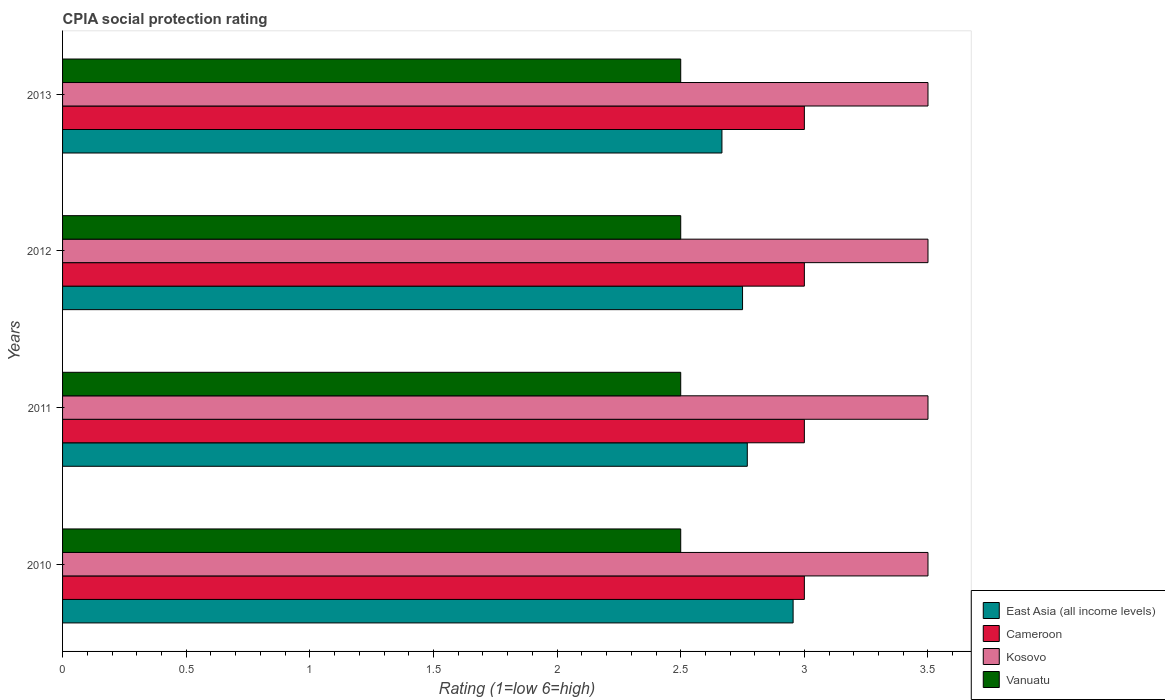How many different coloured bars are there?
Your response must be concise. 4. How many groups of bars are there?
Ensure brevity in your answer.  4. Are the number of bars per tick equal to the number of legend labels?
Your answer should be compact. Yes. Are the number of bars on each tick of the Y-axis equal?
Provide a short and direct response. Yes. How many bars are there on the 3rd tick from the top?
Your answer should be compact. 4. How many bars are there on the 1st tick from the bottom?
Your answer should be compact. 4. What is the label of the 2nd group of bars from the top?
Give a very brief answer. 2012. In how many cases, is the number of bars for a given year not equal to the number of legend labels?
Your answer should be very brief. 0. Across all years, what is the maximum CPIA rating in Cameroon?
Offer a terse response. 3. In which year was the CPIA rating in Vanuatu minimum?
Offer a very short reply. 2010. What is the difference between the CPIA rating in Cameroon in 2010 and that in 2013?
Give a very brief answer. 0. What is the ratio of the CPIA rating in East Asia (all income levels) in 2012 to that in 2013?
Your response must be concise. 1.03. Is the difference between the CPIA rating in East Asia (all income levels) in 2010 and 2012 greater than the difference between the CPIA rating in Cameroon in 2010 and 2012?
Give a very brief answer. Yes. What is the difference between the highest and the lowest CPIA rating in Cameroon?
Your response must be concise. 0. In how many years, is the CPIA rating in Kosovo greater than the average CPIA rating in Kosovo taken over all years?
Provide a succinct answer. 0. Is it the case that in every year, the sum of the CPIA rating in Cameroon and CPIA rating in East Asia (all income levels) is greater than the sum of CPIA rating in Kosovo and CPIA rating in Vanuatu?
Your answer should be compact. No. What does the 1st bar from the top in 2010 represents?
Your response must be concise. Vanuatu. What does the 4th bar from the bottom in 2011 represents?
Provide a short and direct response. Vanuatu. Is it the case that in every year, the sum of the CPIA rating in Vanuatu and CPIA rating in East Asia (all income levels) is greater than the CPIA rating in Cameroon?
Ensure brevity in your answer.  Yes. How many bars are there?
Give a very brief answer. 16. Are all the bars in the graph horizontal?
Your response must be concise. Yes. How many years are there in the graph?
Your answer should be compact. 4. What is the difference between two consecutive major ticks on the X-axis?
Provide a succinct answer. 0.5. Are the values on the major ticks of X-axis written in scientific E-notation?
Offer a terse response. No. Where does the legend appear in the graph?
Give a very brief answer. Bottom right. How are the legend labels stacked?
Keep it short and to the point. Vertical. What is the title of the graph?
Give a very brief answer. CPIA social protection rating. Does "Iceland" appear as one of the legend labels in the graph?
Your answer should be compact. No. What is the label or title of the Y-axis?
Your answer should be very brief. Years. What is the Rating (1=low 6=high) in East Asia (all income levels) in 2010?
Offer a very short reply. 2.95. What is the Rating (1=low 6=high) of Cameroon in 2010?
Provide a short and direct response. 3. What is the Rating (1=low 6=high) of Kosovo in 2010?
Give a very brief answer. 3.5. What is the Rating (1=low 6=high) in East Asia (all income levels) in 2011?
Provide a short and direct response. 2.77. What is the Rating (1=low 6=high) in Cameroon in 2011?
Offer a terse response. 3. What is the Rating (1=low 6=high) of Vanuatu in 2011?
Your answer should be very brief. 2.5. What is the Rating (1=low 6=high) in East Asia (all income levels) in 2012?
Make the answer very short. 2.75. What is the Rating (1=low 6=high) in Kosovo in 2012?
Give a very brief answer. 3.5. What is the Rating (1=low 6=high) of Vanuatu in 2012?
Provide a short and direct response. 2.5. What is the Rating (1=low 6=high) of East Asia (all income levels) in 2013?
Give a very brief answer. 2.67. What is the Rating (1=low 6=high) of Cameroon in 2013?
Your answer should be very brief. 3. Across all years, what is the maximum Rating (1=low 6=high) in East Asia (all income levels)?
Provide a short and direct response. 2.95. Across all years, what is the maximum Rating (1=low 6=high) in Cameroon?
Offer a terse response. 3. Across all years, what is the maximum Rating (1=low 6=high) of Vanuatu?
Offer a very short reply. 2.5. Across all years, what is the minimum Rating (1=low 6=high) in East Asia (all income levels)?
Your answer should be very brief. 2.67. Across all years, what is the minimum Rating (1=low 6=high) of Vanuatu?
Your response must be concise. 2.5. What is the total Rating (1=low 6=high) in East Asia (all income levels) in the graph?
Offer a very short reply. 11.14. What is the total Rating (1=low 6=high) in Cameroon in the graph?
Provide a short and direct response. 12. What is the total Rating (1=low 6=high) of Kosovo in the graph?
Your answer should be very brief. 14. What is the total Rating (1=low 6=high) of Vanuatu in the graph?
Keep it short and to the point. 10. What is the difference between the Rating (1=low 6=high) in East Asia (all income levels) in 2010 and that in 2011?
Provide a short and direct response. 0.19. What is the difference between the Rating (1=low 6=high) of Vanuatu in 2010 and that in 2011?
Make the answer very short. 0. What is the difference between the Rating (1=low 6=high) of East Asia (all income levels) in 2010 and that in 2012?
Keep it short and to the point. 0.2. What is the difference between the Rating (1=low 6=high) in Cameroon in 2010 and that in 2012?
Keep it short and to the point. 0. What is the difference between the Rating (1=low 6=high) of East Asia (all income levels) in 2010 and that in 2013?
Your answer should be compact. 0.29. What is the difference between the Rating (1=low 6=high) of Vanuatu in 2010 and that in 2013?
Provide a short and direct response. 0. What is the difference between the Rating (1=low 6=high) of East Asia (all income levels) in 2011 and that in 2012?
Provide a succinct answer. 0.02. What is the difference between the Rating (1=low 6=high) in East Asia (all income levels) in 2011 and that in 2013?
Make the answer very short. 0.1. What is the difference between the Rating (1=low 6=high) of Kosovo in 2011 and that in 2013?
Your response must be concise. 0. What is the difference between the Rating (1=low 6=high) of Vanuatu in 2011 and that in 2013?
Keep it short and to the point. 0. What is the difference between the Rating (1=low 6=high) in East Asia (all income levels) in 2012 and that in 2013?
Provide a succinct answer. 0.08. What is the difference between the Rating (1=low 6=high) in Cameroon in 2012 and that in 2013?
Offer a very short reply. 0. What is the difference between the Rating (1=low 6=high) in Kosovo in 2012 and that in 2013?
Your response must be concise. 0. What is the difference between the Rating (1=low 6=high) of Vanuatu in 2012 and that in 2013?
Your answer should be compact. 0. What is the difference between the Rating (1=low 6=high) of East Asia (all income levels) in 2010 and the Rating (1=low 6=high) of Cameroon in 2011?
Offer a terse response. -0.05. What is the difference between the Rating (1=low 6=high) of East Asia (all income levels) in 2010 and the Rating (1=low 6=high) of Kosovo in 2011?
Ensure brevity in your answer.  -0.55. What is the difference between the Rating (1=low 6=high) in East Asia (all income levels) in 2010 and the Rating (1=low 6=high) in Vanuatu in 2011?
Provide a short and direct response. 0.45. What is the difference between the Rating (1=low 6=high) of Cameroon in 2010 and the Rating (1=low 6=high) of Vanuatu in 2011?
Make the answer very short. 0.5. What is the difference between the Rating (1=low 6=high) in East Asia (all income levels) in 2010 and the Rating (1=low 6=high) in Cameroon in 2012?
Ensure brevity in your answer.  -0.05. What is the difference between the Rating (1=low 6=high) in East Asia (all income levels) in 2010 and the Rating (1=low 6=high) in Kosovo in 2012?
Keep it short and to the point. -0.55. What is the difference between the Rating (1=low 6=high) of East Asia (all income levels) in 2010 and the Rating (1=low 6=high) of Vanuatu in 2012?
Keep it short and to the point. 0.45. What is the difference between the Rating (1=low 6=high) of Cameroon in 2010 and the Rating (1=low 6=high) of Kosovo in 2012?
Your response must be concise. -0.5. What is the difference between the Rating (1=low 6=high) of Cameroon in 2010 and the Rating (1=low 6=high) of Vanuatu in 2012?
Keep it short and to the point. 0.5. What is the difference between the Rating (1=low 6=high) of East Asia (all income levels) in 2010 and the Rating (1=low 6=high) of Cameroon in 2013?
Your answer should be very brief. -0.05. What is the difference between the Rating (1=low 6=high) in East Asia (all income levels) in 2010 and the Rating (1=low 6=high) in Kosovo in 2013?
Offer a terse response. -0.55. What is the difference between the Rating (1=low 6=high) in East Asia (all income levels) in 2010 and the Rating (1=low 6=high) in Vanuatu in 2013?
Make the answer very short. 0.45. What is the difference between the Rating (1=low 6=high) in Cameroon in 2010 and the Rating (1=low 6=high) in Vanuatu in 2013?
Provide a succinct answer. 0.5. What is the difference between the Rating (1=low 6=high) in Kosovo in 2010 and the Rating (1=low 6=high) in Vanuatu in 2013?
Offer a terse response. 1. What is the difference between the Rating (1=low 6=high) in East Asia (all income levels) in 2011 and the Rating (1=low 6=high) in Cameroon in 2012?
Make the answer very short. -0.23. What is the difference between the Rating (1=low 6=high) of East Asia (all income levels) in 2011 and the Rating (1=low 6=high) of Kosovo in 2012?
Your response must be concise. -0.73. What is the difference between the Rating (1=low 6=high) of East Asia (all income levels) in 2011 and the Rating (1=low 6=high) of Vanuatu in 2012?
Give a very brief answer. 0.27. What is the difference between the Rating (1=low 6=high) of Cameroon in 2011 and the Rating (1=low 6=high) of Vanuatu in 2012?
Your answer should be very brief. 0.5. What is the difference between the Rating (1=low 6=high) in East Asia (all income levels) in 2011 and the Rating (1=low 6=high) in Cameroon in 2013?
Make the answer very short. -0.23. What is the difference between the Rating (1=low 6=high) of East Asia (all income levels) in 2011 and the Rating (1=low 6=high) of Kosovo in 2013?
Give a very brief answer. -0.73. What is the difference between the Rating (1=low 6=high) of East Asia (all income levels) in 2011 and the Rating (1=low 6=high) of Vanuatu in 2013?
Your response must be concise. 0.27. What is the difference between the Rating (1=low 6=high) of Cameroon in 2011 and the Rating (1=low 6=high) of Kosovo in 2013?
Your answer should be very brief. -0.5. What is the difference between the Rating (1=low 6=high) of Cameroon in 2011 and the Rating (1=low 6=high) of Vanuatu in 2013?
Make the answer very short. 0.5. What is the difference between the Rating (1=low 6=high) of East Asia (all income levels) in 2012 and the Rating (1=low 6=high) of Kosovo in 2013?
Your answer should be compact. -0.75. What is the difference between the Rating (1=low 6=high) of Cameroon in 2012 and the Rating (1=low 6=high) of Kosovo in 2013?
Provide a succinct answer. -0.5. What is the difference between the Rating (1=low 6=high) in Kosovo in 2012 and the Rating (1=low 6=high) in Vanuatu in 2013?
Give a very brief answer. 1. What is the average Rating (1=low 6=high) in East Asia (all income levels) per year?
Keep it short and to the point. 2.79. What is the average Rating (1=low 6=high) of Cameroon per year?
Make the answer very short. 3. What is the average Rating (1=low 6=high) in Kosovo per year?
Offer a very short reply. 3.5. What is the average Rating (1=low 6=high) of Vanuatu per year?
Your answer should be compact. 2.5. In the year 2010, what is the difference between the Rating (1=low 6=high) of East Asia (all income levels) and Rating (1=low 6=high) of Cameroon?
Provide a short and direct response. -0.05. In the year 2010, what is the difference between the Rating (1=low 6=high) of East Asia (all income levels) and Rating (1=low 6=high) of Kosovo?
Keep it short and to the point. -0.55. In the year 2010, what is the difference between the Rating (1=low 6=high) of East Asia (all income levels) and Rating (1=low 6=high) of Vanuatu?
Offer a terse response. 0.45. In the year 2010, what is the difference between the Rating (1=low 6=high) in Cameroon and Rating (1=low 6=high) in Vanuatu?
Make the answer very short. 0.5. In the year 2011, what is the difference between the Rating (1=low 6=high) of East Asia (all income levels) and Rating (1=low 6=high) of Cameroon?
Provide a short and direct response. -0.23. In the year 2011, what is the difference between the Rating (1=low 6=high) of East Asia (all income levels) and Rating (1=low 6=high) of Kosovo?
Keep it short and to the point. -0.73. In the year 2011, what is the difference between the Rating (1=low 6=high) of East Asia (all income levels) and Rating (1=low 6=high) of Vanuatu?
Your response must be concise. 0.27. In the year 2011, what is the difference between the Rating (1=low 6=high) in Cameroon and Rating (1=low 6=high) in Kosovo?
Your answer should be compact. -0.5. In the year 2011, what is the difference between the Rating (1=low 6=high) of Kosovo and Rating (1=low 6=high) of Vanuatu?
Provide a succinct answer. 1. In the year 2012, what is the difference between the Rating (1=low 6=high) in East Asia (all income levels) and Rating (1=low 6=high) in Kosovo?
Provide a succinct answer. -0.75. In the year 2012, what is the difference between the Rating (1=low 6=high) in East Asia (all income levels) and Rating (1=low 6=high) in Vanuatu?
Your answer should be very brief. 0.25. In the year 2012, what is the difference between the Rating (1=low 6=high) in Cameroon and Rating (1=low 6=high) in Vanuatu?
Ensure brevity in your answer.  0.5. In the year 2013, what is the difference between the Rating (1=low 6=high) of East Asia (all income levels) and Rating (1=low 6=high) of Kosovo?
Provide a succinct answer. -0.83. In the year 2013, what is the difference between the Rating (1=low 6=high) of East Asia (all income levels) and Rating (1=low 6=high) of Vanuatu?
Offer a terse response. 0.17. In the year 2013, what is the difference between the Rating (1=low 6=high) of Cameroon and Rating (1=low 6=high) of Kosovo?
Give a very brief answer. -0.5. What is the ratio of the Rating (1=low 6=high) in East Asia (all income levels) in 2010 to that in 2011?
Your answer should be very brief. 1.07. What is the ratio of the Rating (1=low 6=high) in East Asia (all income levels) in 2010 to that in 2012?
Provide a succinct answer. 1.07. What is the ratio of the Rating (1=low 6=high) of Kosovo in 2010 to that in 2012?
Your response must be concise. 1. What is the ratio of the Rating (1=low 6=high) of Vanuatu in 2010 to that in 2012?
Ensure brevity in your answer.  1. What is the ratio of the Rating (1=low 6=high) of East Asia (all income levels) in 2010 to that in 2013?
Make the answer very short. 1.11. What is the ratio of the Rating (1=low 6=high) of Kosovo in 2010 to that in 2013?
Keep it short and to the point. 1. What is the ratio of the Rating (1=low 6=high) in Vanuatu in 2010 to that in 2013?
Offer a very short reply. 1. What is the ratio of the Rating (1=low 6=high) in East Asia (all income levels) in 2011 to that in 2012?
Give a very brief answer. 1.01. What is the ratio of the Rating (1=low 6=high) of Cameroon in 2011 to that in 2012?
Offer a terse response. 1. What is the ratio of the Rating (1=low 6=high) of Kosovo in 2011 to that in 2012?
Keep it short and to the point. 1. What is the ratio of the Rating (1=low 6=high) of Vanuatu in 2011 to that in 2012?
Provide a short and direct response. 1. What is the ratio of the Rating (1=low 6=high) of East Asia (all income levels) in 2012 to that in 2013?
Offer a terse response. 1.03. What is the ratio of the Rating (1=low 6=high) of Kosovo in 2012 to that in 2013?
Provide a short and direct response. 1. What is the difference between the highest and the second highest Rating (1=low 6=high) of East Asia (all income levels)?
Provide a short and direct response. 0.19. What is the difference between the highest and the second highest Rating (1=low 6=high) of Cameroon?
Your response must be concise. 0. What is the difference between the highest and the lowest Rating (1=low 6=high) in East Asia (all income levels)?
Your response must be concise. 0.29. What is the difference between the highest and the lowest Rating (1=low 6=high) in Kosovo?
Make the answer very short. 0. 